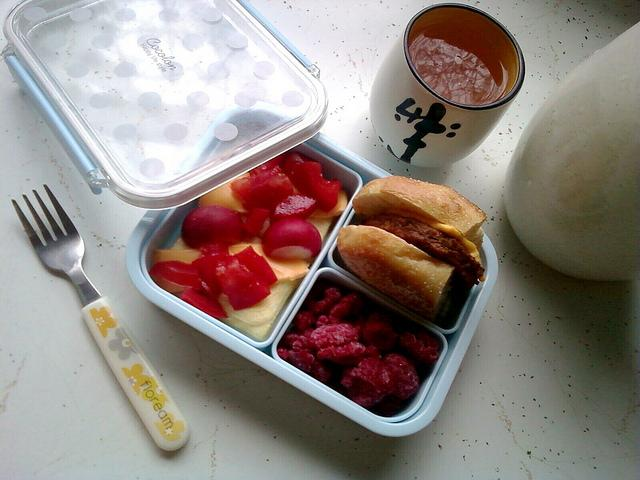What item resembles the item all the way to the left?

Choices:
A) buzzsaw
B) pitchfork
C) chainsaw
D) gramophone pitchfork 